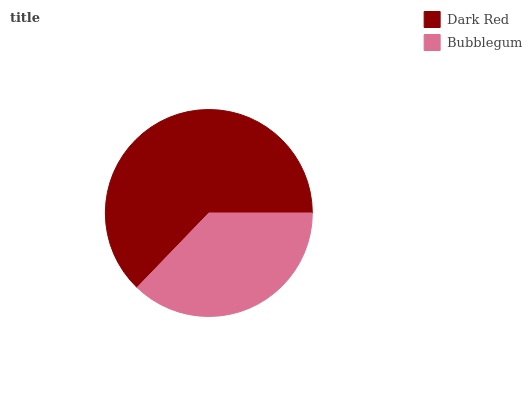Is Bubblegum the minimum?
Answer yes or no. Yes. Is Dark Red the maximum?
Answer yes or no. Yes. Is Bubblegum the maximum?
Answer yes or no. No. Is Dark Red greater than Bubblegum?
Answer yes or no. Yes. Is Bubblegum less than Dark Red?
Answer yes or no. Yes. Is Bubblegum greater than Dark Red?
Answer yes or no. No. Is Dark Red less than Bubblegum?
Answer yes or no. No. Is Dark Red the high median?
Answer yes or no. Yes. Is Bubblegum the low median?
Answer yes or no. Yes. Is Bubblegum the high median?
Answer yes or no. No. Is Dark Red the low median?
Answer yes or no. No. 